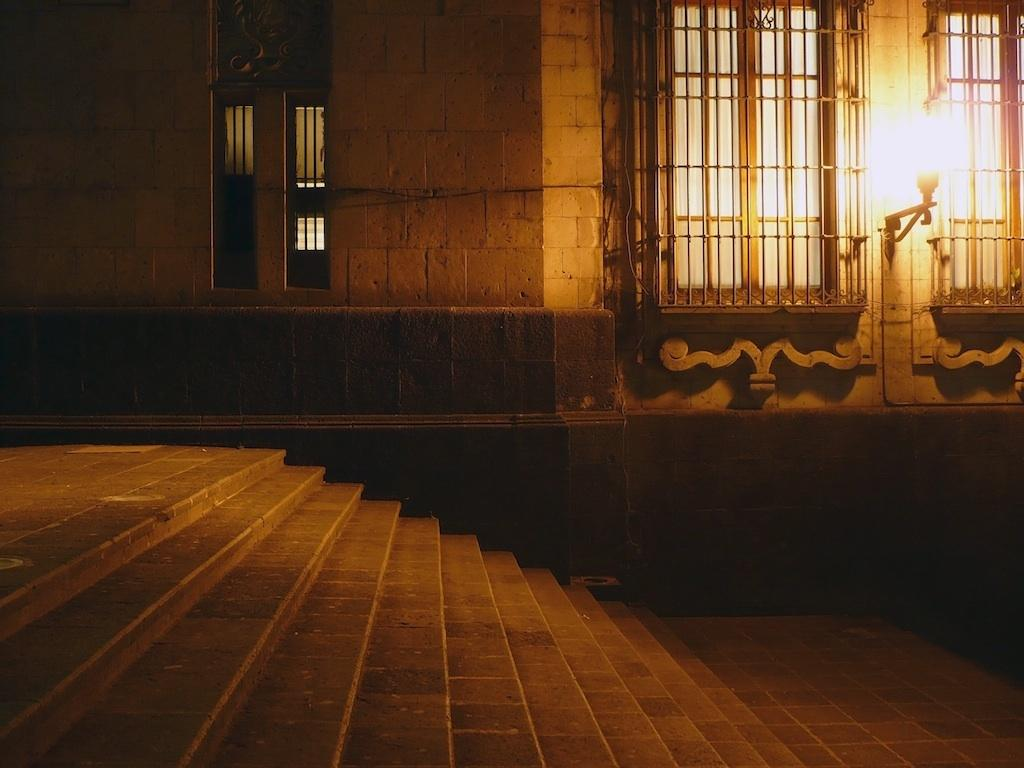What is located at the bottom of the image? There are stairs at the bottom of the image. What can be seen in the background of the image? There are windows and a wall in the background of the image. Can you describe the lighting in the image? There is light visible in the image. What type of cushion is placed on the spot in the image? There is no cushion or spot present in the image. 